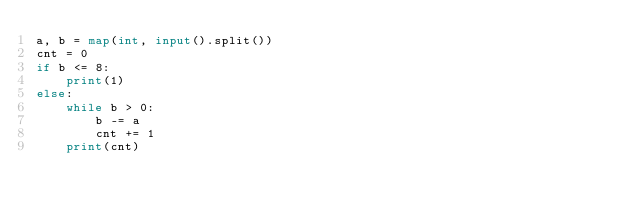<code> <loc_0><loc_0><loc_500><loc_500><_Python_>a, b = map(int, input().split())
cnt = 0
if b <= 8:
    print(1)
else:
    while b > 0:
        b -= a
        cnt += 1
    print(cnt)
</code> 